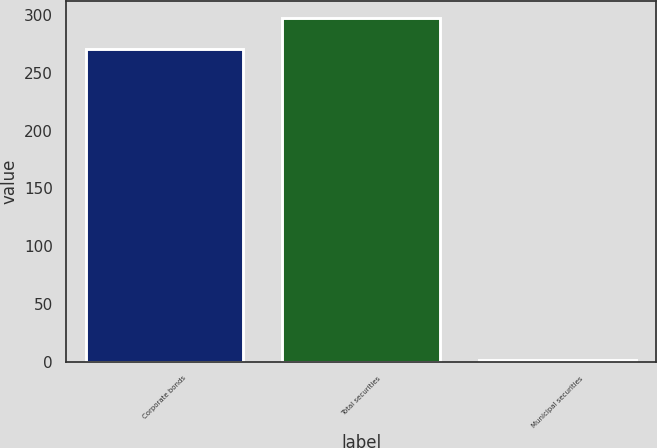Convert chart to OTSL. <chart><loc_0><loc_0><loc_500><loc_500><bar_chart><fcel>Corporate bonds<fcel>Total securities<fcel>Municipal securities<nl><fcel>270<fcel>296.8<fcel>2<nl></chart> 